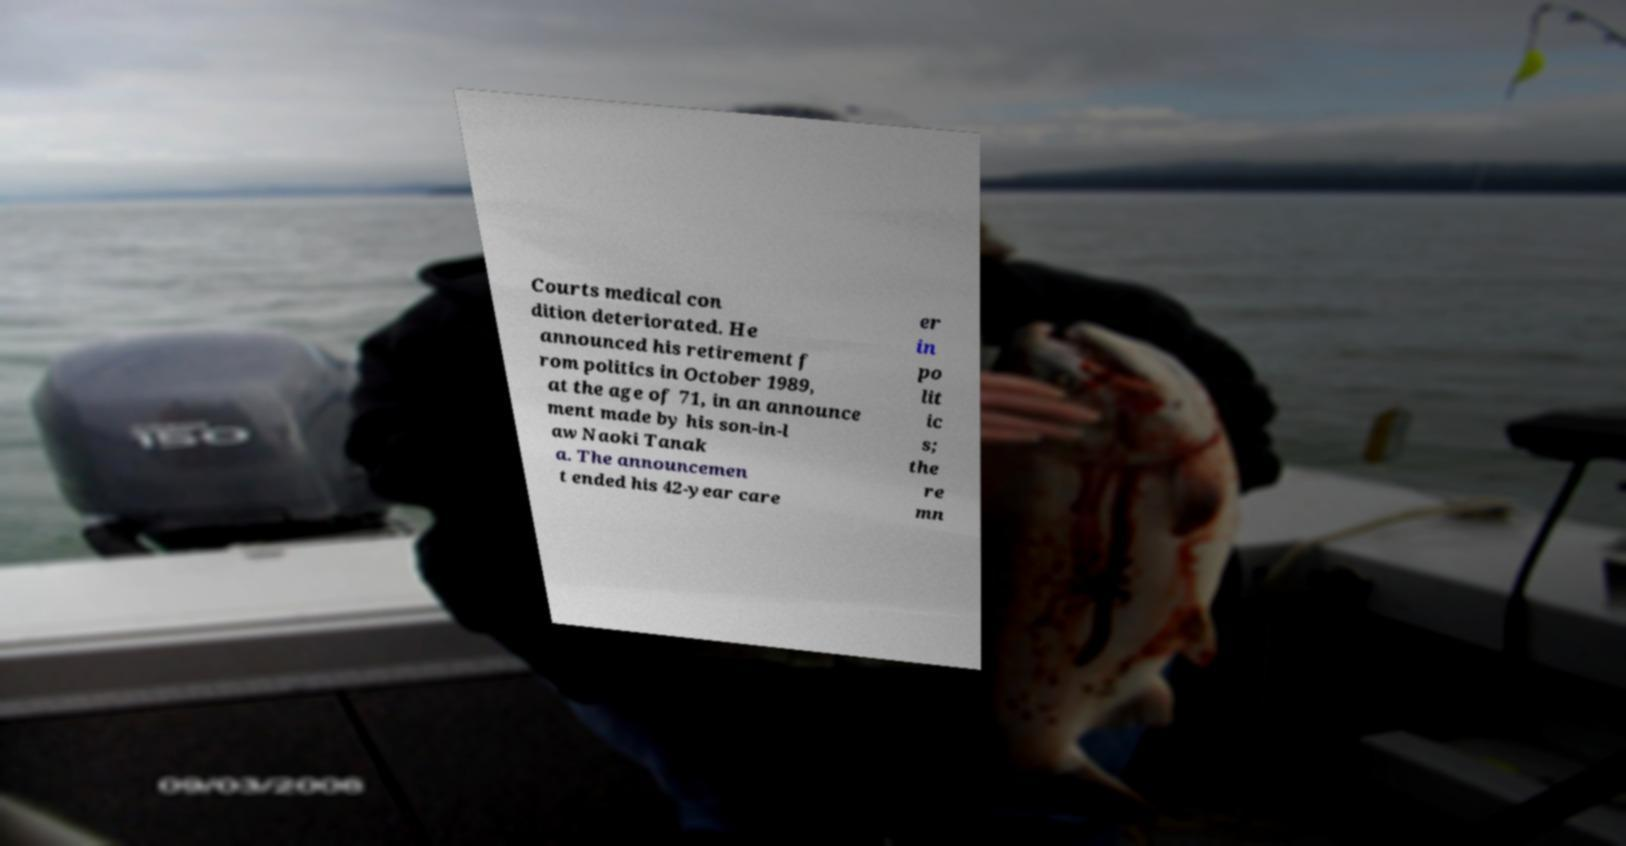What messages or text are displayed in this image? I need them in a readable, typed format. Courts medical con dition deteriorated. He announced his retirement f rom politics in October 1989, at the age of 71, in an announce ment made by his son-in-l aw Naoki Tanak a. The announcemen t ended his 42-year care er in po lit ic s; the re mn 